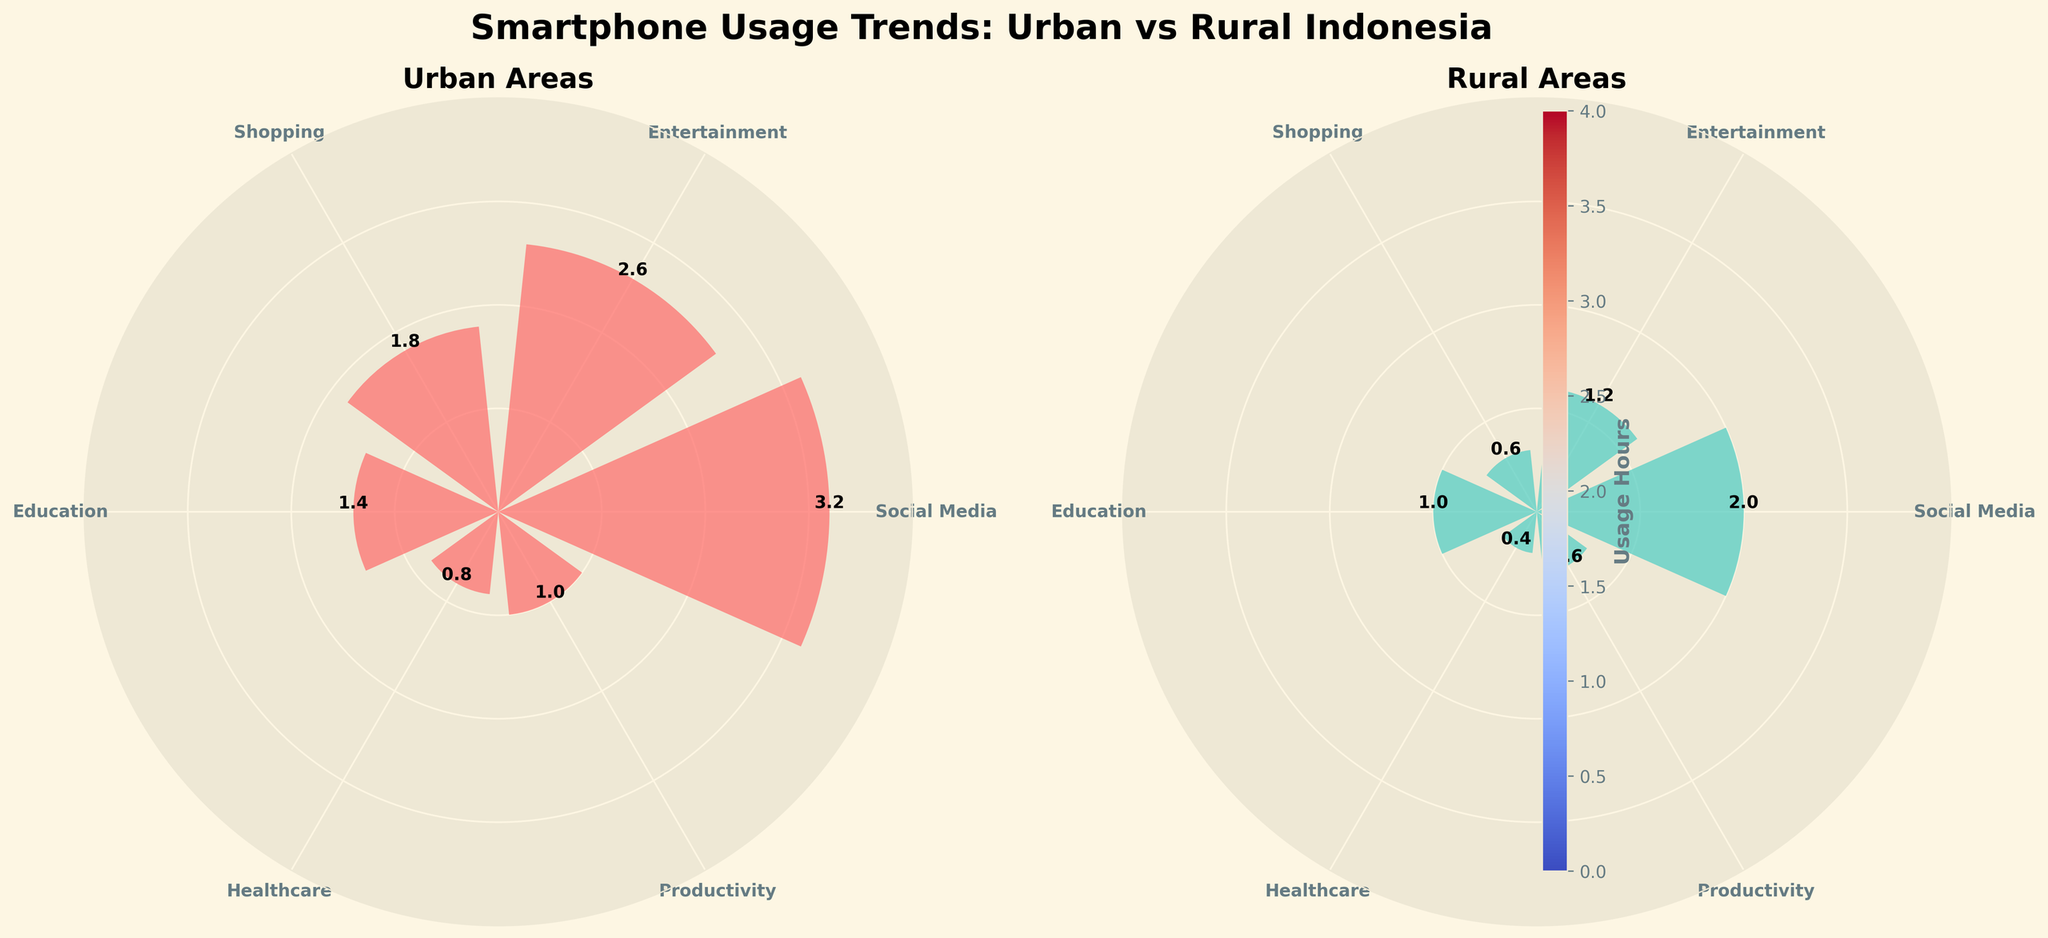What is the title of the figure? The title is displayed at the top of the figure in bold, large font. It reads "Smartphone Usage Trends: Urban vs Rural Indonesia".
Answer: Smartphone Usage Trends: Urban vs Rural Indonesia Which application has the highest usage in urban areas? In the urban area subplot, the largest bar corresponds to 'Social Media' with a usage of 3.2 hours.
Answer: Social Media How many applications are compared in each area? Both the urban and rural plots have an equal number of bars representing applications. Counting these bars, we get six applications.
Answer: Six What is the total smartphone usage hours for entertainment applications in both areas? From the figure, the urban usage for entertainment is 2.6 hours, and rural usage is 1.2 hours. Adding these together: 2.6 + 1.2 = 3.8 hours.
Answer: 3.8 hours Which area has higher healthcare application usage? Comparing the heights of the bars labeled as 'Healthcare' in both plots, the urban area has 0.8 hours while the rural area has 0.4 hours.
Answer: Urban How much more time do urban users spend on shopping applications compared to rural users? The urban area shows 1.8 hours, and the rural area shows 0.6 hours. The difference is calculated as 1.8 - 0.6 = 1.2 hours.
Answer: 1.2 hours Calculate the average usage hours for productivity applications across both areas. The urban usage is 1.0 hours, and the rural usage is 0.6 hours. The average is (1.0 + 0.6) / 2 = 0.8 hours.
Answer: 0.8 hours Which application has the smallest difference in usage between urban and rural areas? By examining the differences: Social Media (1.2), Entertainment (1.4), Shopping (1.2), Education (0.4), Healthcare (0.4), Productivity (0.4), the smallest differences are Education (0.4), Healthcare (0.4), and Productivity (0.4).
Answer: Education / Healthcare / Productivity Which area has more diverse application usage in terms of range? The range for each area is the difference between the maximum and minimum usage hours. Urban: max (3.2) - min (0.8) = 2.4; Rural: max (2.0) - min (0.4) = 1.6. Urban has a larger range, hence more diverse usage.
Answer: Urban 